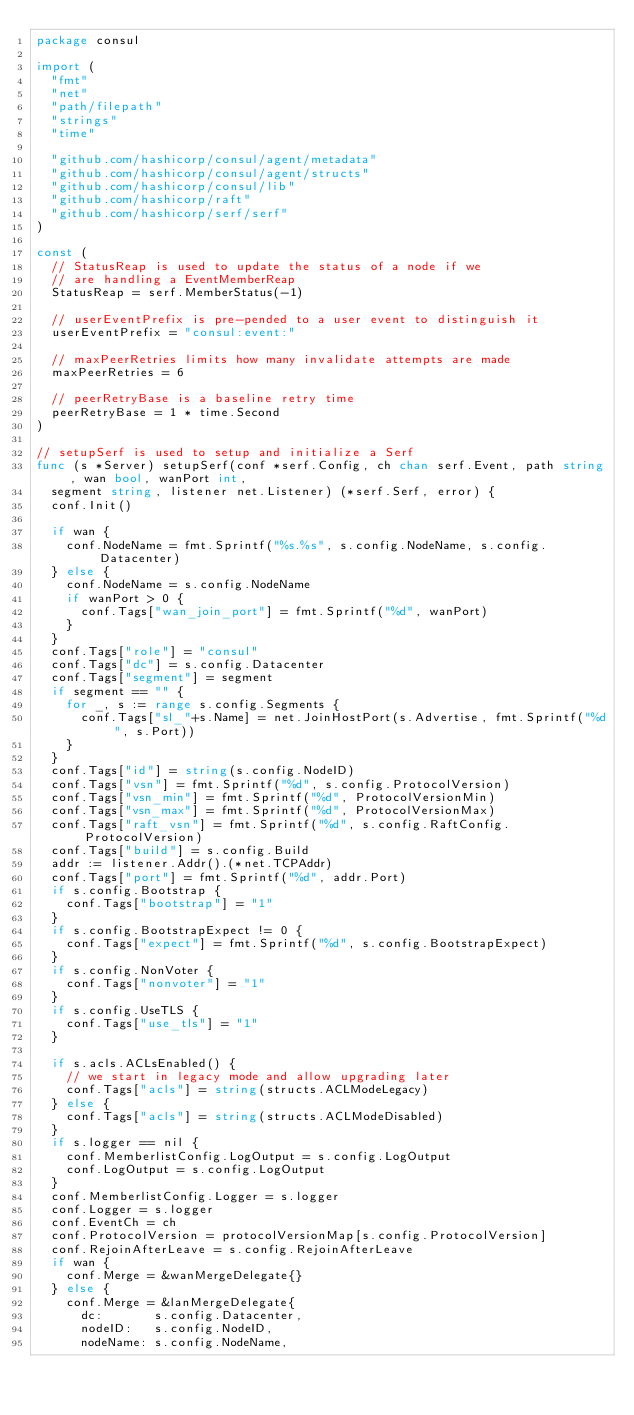<code> <loc_0><loc_0><loc_500><loc_500><_Go_>package consul

import (
	"fmt"
	"net"
	"path/filepath"
	"strings"
	"time"

	"github.com/hashicorp/consul/agent/metadata"
	"github.com/hashicorp/consul/agent/structs"
	"github.com/hashicorp/consul/lib"
	"github.com/hashicorp/raft"
	"github.com/hashicorp/serf/serf"
)

const (
	// StatusReap is used to update the status of a node if we
	// are handling a EventMemberReap
	StatusReap = serf.MemberStatus(-1)

	// userEventPrefix is pre-pended to a user event to distinguish it
	userEventPrefix = "consul:event:"

	// maxPeerRetries limits how many invalidate attempts are made
	maxPeerRetries = 6

	// peerRetryBase is a baseline retry time
	peerRetryBase = 1 * time.Second
)

// setupSerf is used to setup and initialize a Serf
func (s *Server) setupSerf(conf *serf.Config, ch chan serf.Event, path string, wan bool, wanPort int,
	segment string, listener net.Listener) (*serf.Serf, error) {
	conf.Init()

	if wan {
		conf.NodeName = fmt.Sprintf("%s.%s", s.config.NodeName, s.config.Datacenter)
	} else {
		conf.NodeName = s.config.NodeName
		if wanPort > 0 {
			conf.Tags["wan_join_port"] = fmt.Sprintf("%d", wanPort)
		}
	}
	conf.Tags["role"] = "consul"
	conf.Tags["dc"] = s.config.Datacenter
	conf.Tags["segment"] = segment
	if segment == "" {
		for _, s := range s.config.Segments {
			conf.Tags["sl_"+s.Name] = net.JoinHostPort(s.Advertise, fmt.Sprintf("%d", s.Port))
		}
	}
	conf.Tags["id"] = string(s.config.NodeID)
	conf.Tags["vsn"] = fmt.Sprintf("%d", s.config.ProtocolVersion)
	conf.Tags["vsn_min"] = fmt.Sprintf("%d", ProtocolVersionMin)
	conf.Tags["vsn_max"] = fmt.Sprintf("%d", ProtocolVersionMax)
	conf.Tags["raft_vsn"] = fmt.Sprintf("%d", s.config.RaftConfig.ProtocolVersion)
	conf.Tags["build"] = s.config.Build
	addr := listener.Addr().(*net.TCPAddr)
	conf.Tags["port"] = fmt.Sprintf("%d", addr.Port)
	if s.config.Bootstrap {
		conf.Tags["bootstrap"] = "1"
	}
	if s.config.BootstrapExpect != 0 {
		conf.Tags["expect"] = fmt.Sprintf("%d", s.config.BootstrapExpect)
	}
	if s.config.NonVoter {
		conf.Tags["nonvoter"] = "1"
	}
	if s.config.UseTLS {
		conf.Tags["use_tls"] = "1"
	}

	if s.acls.ACLsEnabled() {
		// we start in legacy mode and allow upgrading later
		conf.Tags["acls"] = string(structs.ACLModeLegacy)
	} else {
		conf.Tags["acls"] = string(structs.ACLModeDisabled)
	}
	if s.logger == nil {
		conf.MemberlistConfig.LogOutput = s.config.LogOutput
		conf.LogOutput = s.config.LogOutput
	}
	conf.MemberlistConfig.Logger = s.logger
	conf.Logger = s.logger
	conf.EventCh = ch
	conf.ProtocolVersion = protocolVersionMap[s.config.ProtocolVersion]
	conf.RejoinAfterLeave = s.config.RejoinAfterLeave
	if wan {
		conf.Merge = &wanMergeDelegate{}
	} else {
		conf.Merge = &lanMergeDelegate{
			dc:       s.config.Datacenter,
			nodeID:   s.config.NodeID,
			nodeName: s.config.NodeName,</code> 